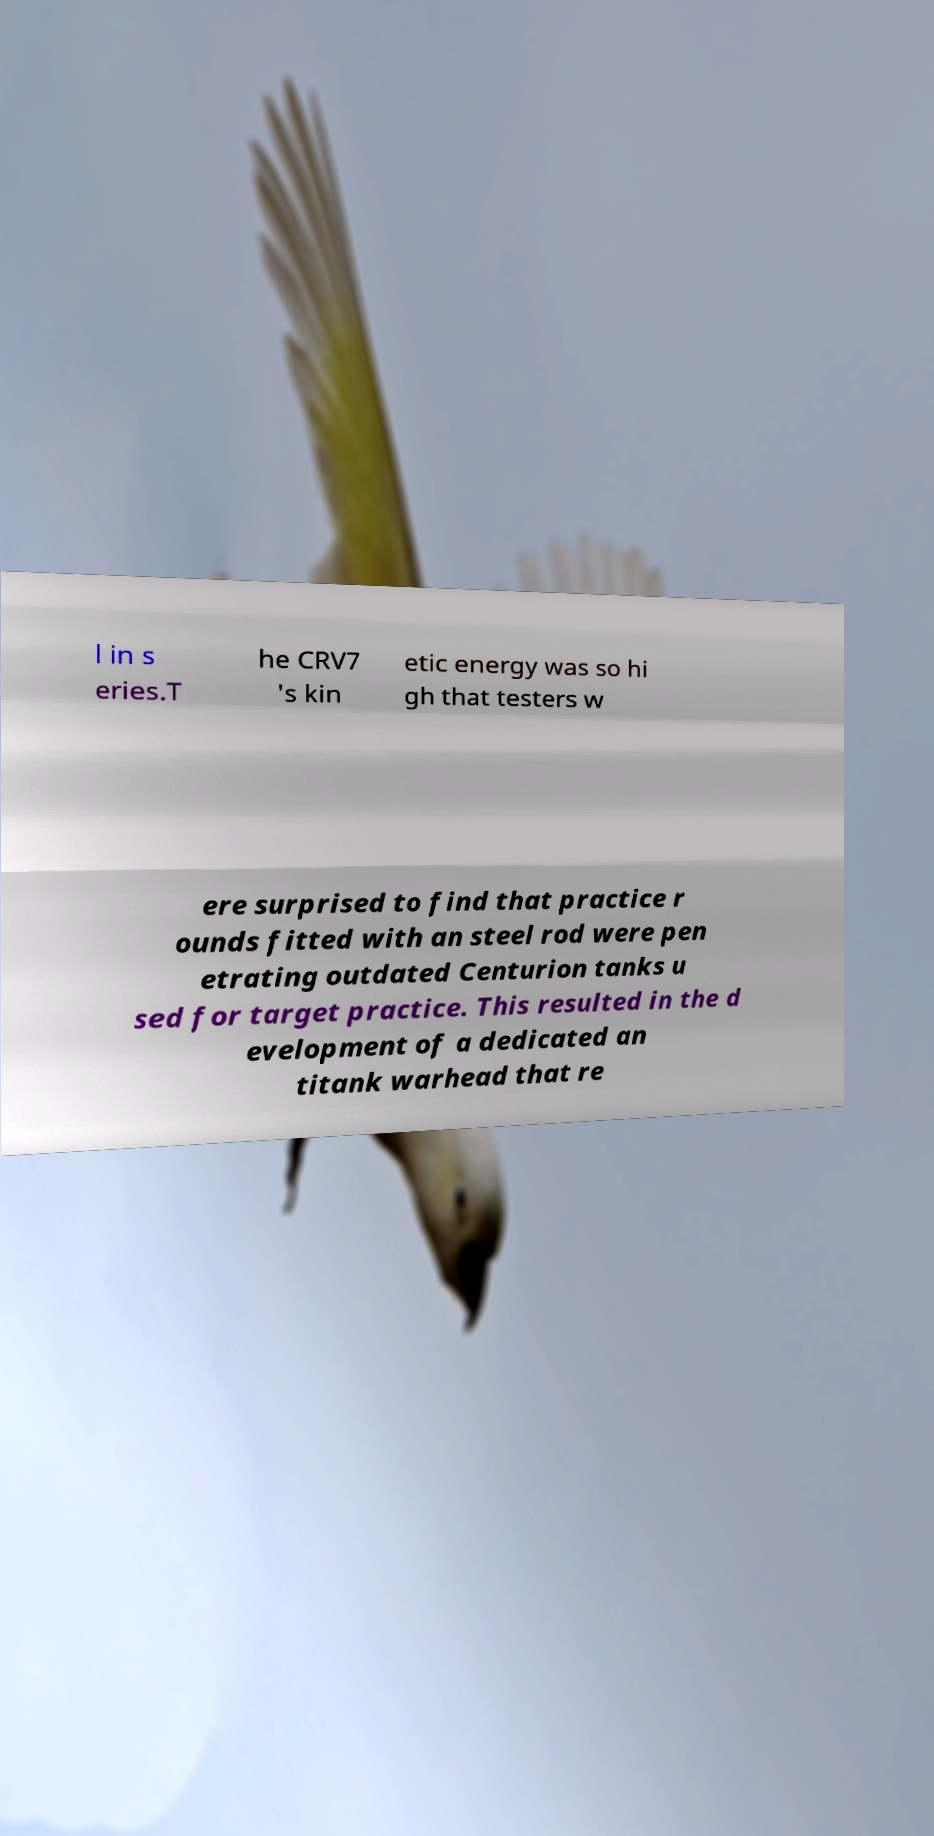There's text embedded in this image that I need extracted. Can you transcribe it verbatim? l in s eries.T he CRV7 's kin etic energy was so hi gh that testers w ere surprised to find that practice r ounds fitted with an steel rod were pen etrating outdated Centurion tanks u sed for target practice. This resulted in the d evelopment of a dedicated an titank warhead that re 